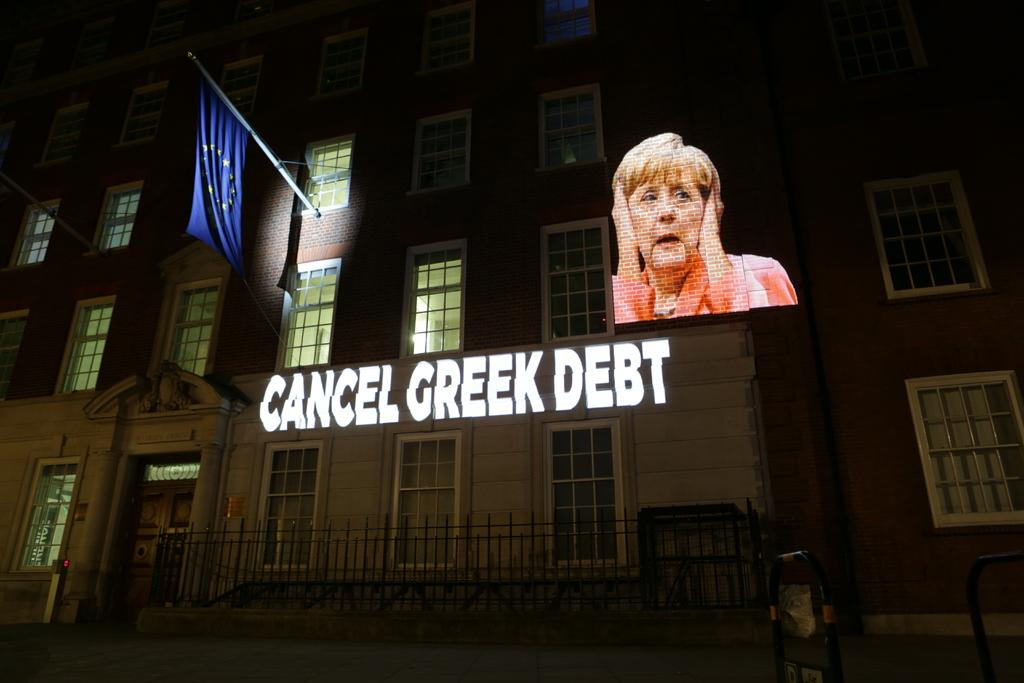What is the main subject in the center of the image? There is a building in the center of the image. What feature can be seen on the building? The building has windows. What is located near the building? There is a flag near the building. What type of information is visible in the image? There is text visible in the image. What can be seen on the wall inside the building? There is a woman's picture on the wall. How would you describe the lighting in the image? The bottom and top parts of the image are dark. What word can be seen smashed into the wilderness in the image? There is no word smashed into the wilderness in the image; the image features a building with windows, a flag, text, and a woman's picture on the wall. 